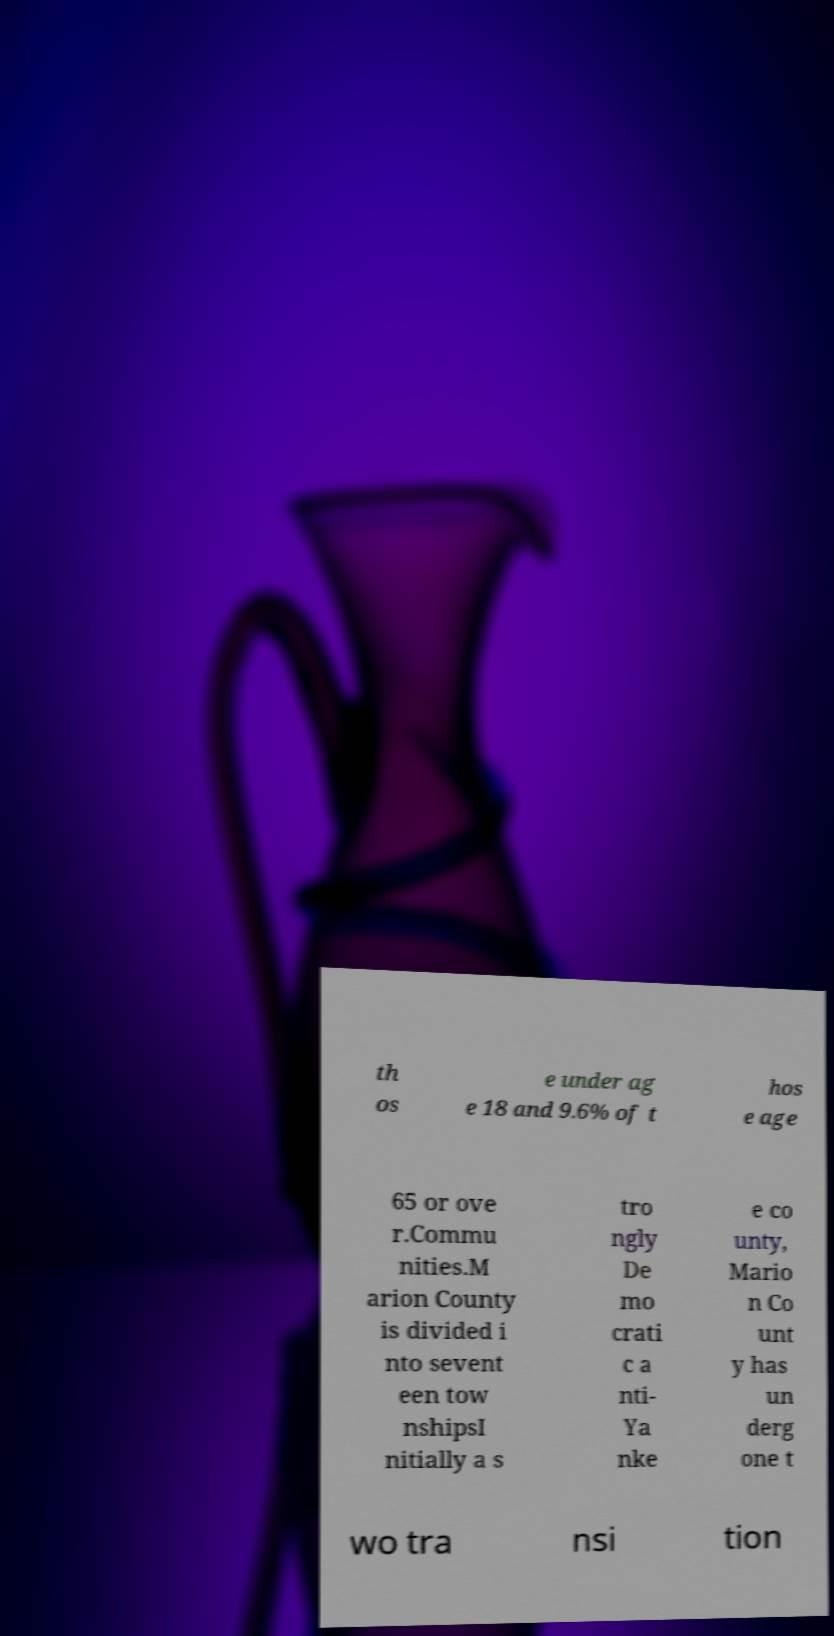What messages or text are displayed in this image? I need them in a readable, typed format. th os e under ag e 18 and 9.6% of t hos e age 65 or ove r.Commu nities.M arion County is divided i nto sevent een tow nshipsI nitially a s tro ngly De mo crati c a nti- Ya nke e co unty, Mario n Co unt y has un derg one t wo tra nsi tion 